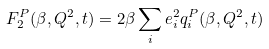<formula> <loc_0><loc_0><loc_500><loc_500>F _ { 2 } ^ { P } ( \beta , Q ^ { 2 } , t ) = 2 \beta \sum _ { i } e _ { i } ^ { 2 } q _ { i } ^ { P } ( \beta , Q ^ { 2 } , t )</formula> 